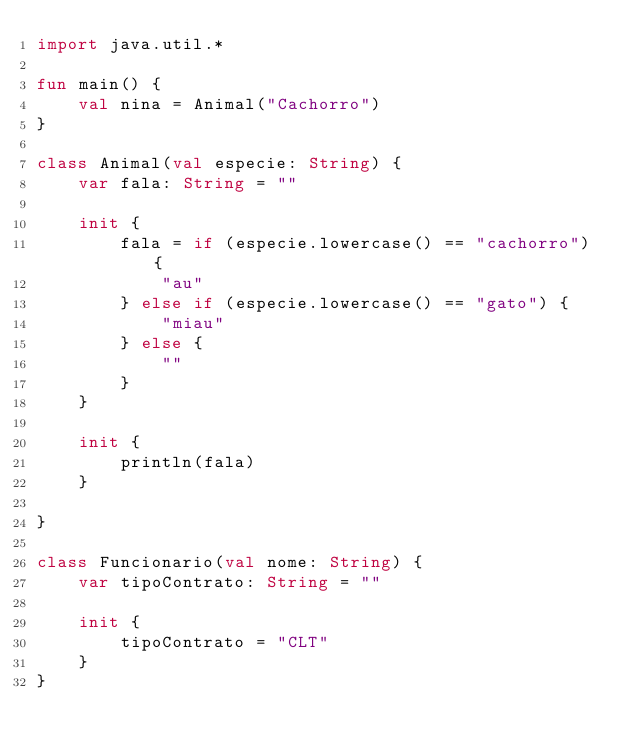<code> <loc_0><loc_0><loc_500><loc_500><_Kotlin_>import java.util.*

fun main() {
    val nina = Animal("Cachorro")
}

class Animal(val especie: String) {
    var fala: String = ""

    init {
        fala = if (especie.lowercase() == "cachorro") {
            "au"
        } else if (especie.lowercase() == "gato") {
            "miau"
        } else {
            ""
        }
    }

    init {
        println(fala)
    }

}

class Funcionario(val nome: String) {
    var tipoContrato: String = ""

    init {
        tipoContrato = "CLT"
    }
}</code> 